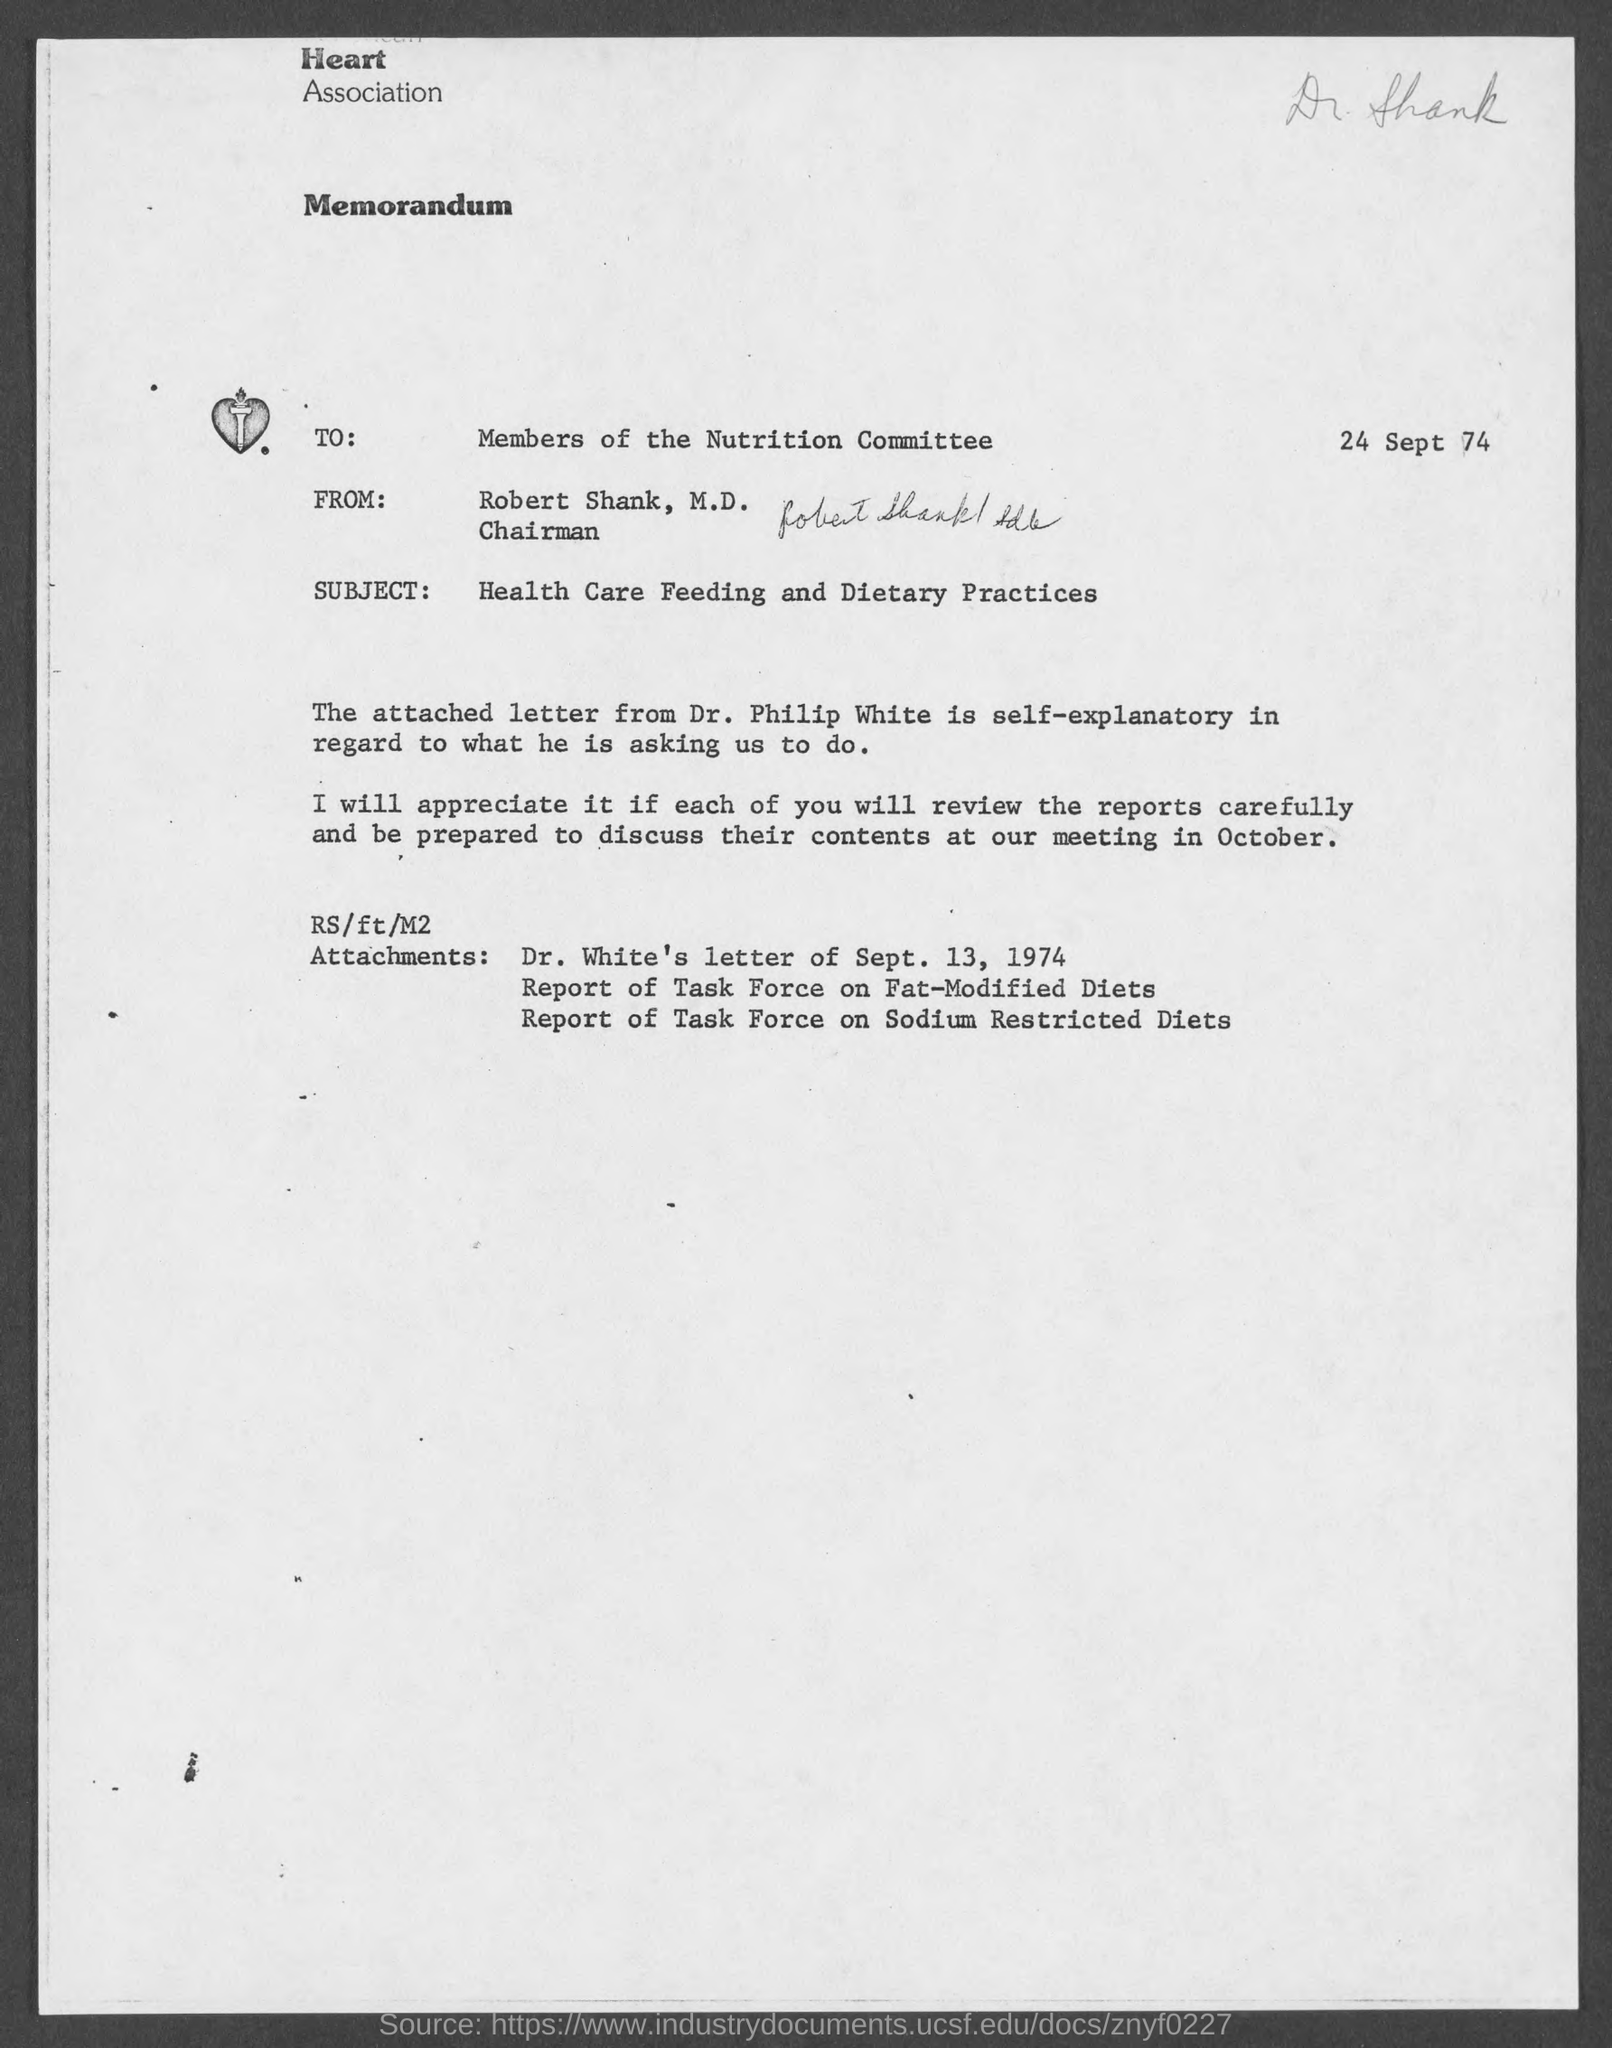When is the memorandum dated?
Offer a terse response. 24 sept 74. What is the subject of memorandum ?
Your answer should be compact. Health Care Feeding and Dietary Practices. To whom is this memorandum written to?
Offer a terse response. Members of nutrition committee. From whom is this memorandum from ?
Give a very brief answer. Robert Shank, M.D. What is the position of robert shank,m.d.?
Offer a terse response. Chairman. 